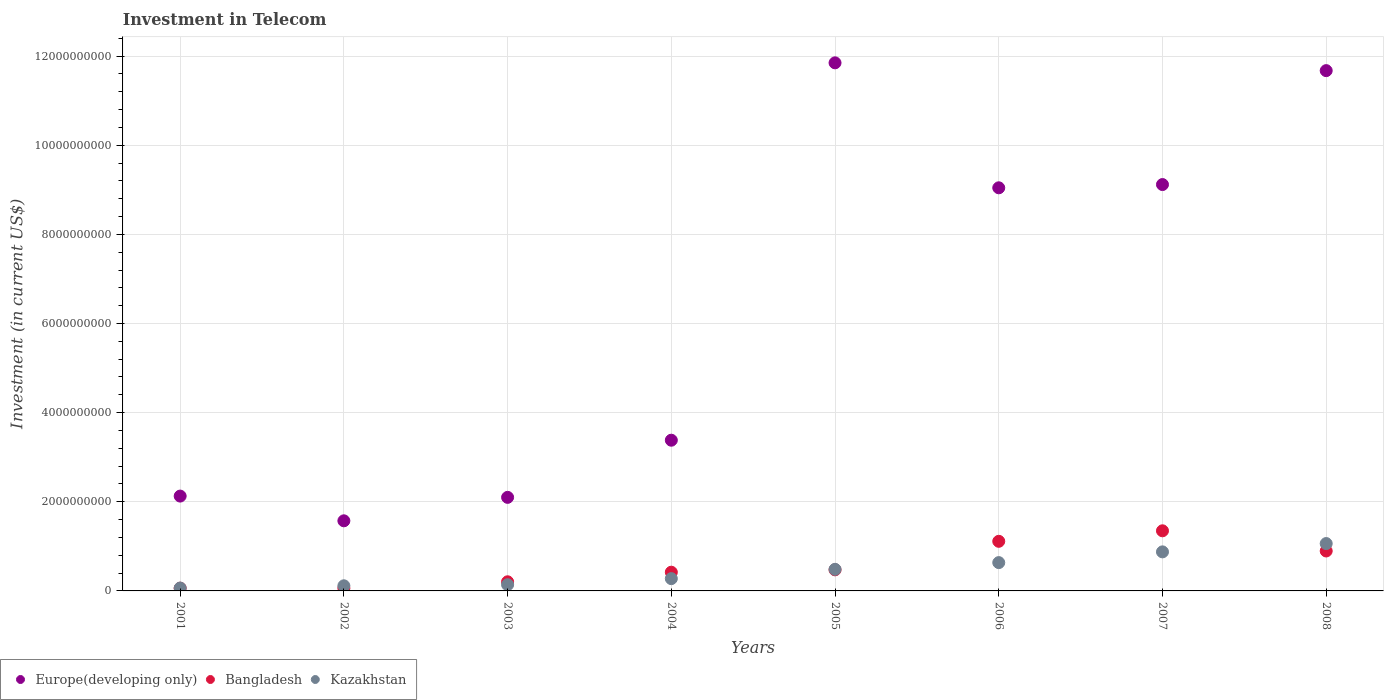What is the amount invested in telecom in Kazakhstan in 2008?
Make the answer very short. 1.06e+09. Across all years, what is the maximum amount invested in telecom in Bangladesh?
Ensure brevity in your answer.  1.35e+09. Across all years, what is the minimum amount invested in telecom in Kazakhstan?
Ensure brevity in your answer.  6.45e+07. In which year was the amount invested in telecom in Europe(developing only) maximum?
Make the answer very short. 2005. In which year was the amount invested in telecom in Europe(developing only) minimum?
Keep it short and to the point. 2002. What is the total amount invested in telecom in Bangladesh in the graph?
Keep it short and to the point. 4.58e+09. What is the difference between the amount invested in telecom in Europe(developing only) in 2005 and that in 2008?
Give a very brief answer. 1.75e+08. What is the difference between the amount invested in telecom in Bangladesh in 2001 and the amount invested in telecom in Kazakhstan in 2007?
Offer a very short reply. -8.15e+08. What is the average amount invested in telecom in Bangladesh per year?
Provide a succinct answer. 5.72e+08. In the year 2003, what is the difference between the amount invested in telecom in Kazakhstan and amount invested in telecom in Bangladesh?
Make the answer very short. -6.60e+07. What is the ratio of the amount invested in telecom in Bangladesh in 2001 to that in 2002?
Give a very brief answer. 1.01. Is the amount invested in telecom in Bangladesh in 2001 less than that in 2007?
Provide a succinct answer. Yes. Is the difference between the amount invested in telecom in Kazakhstan in 2002 and 2005 greater than the difference between the amount invested in telecom in Bangladesh in 2002 and 2005?
Your answer should be compact. Yes. What is the difference between the highest and the second highest amount invested in telecom in Bangladesh?
Make the answer very short. 2.36e+08. What is the difference between the highest and the lowest amount invested in telecom in Bangladesh?
Offer a terse response. 1.29e+09. Is the sum of the amount invested in telecom in Kazakhstan in 2002 and 2003 greater than the maximum amount invested in telecom in Europe(developing only) across all years?
Offer a terse response. No. Is it the case that in every year, the sum of the amount invested in telecom in Kazakhstan and amount invested in telecom in Bangladesh  is greater than the amount invested in telecom in Europe(developing only)?
Your answer should be compact. No. Is the amount invested in telecom in Kazakhstan strictly greater than the amount invested in telecom in Europe(developing only) over the years?
Offer a very short reply. No. What is the difference between two consecutive major ticks on the Y-axis?
Keep it short and to the point. 2.00e+09. Does the graph contain any zero values?
Keep it short and to the point. No. Does the graph contain grids?
Offer a very short reply. Yes. Where does the legend appear in the graph?
Your answer should be compact. Bottom left. How many legend labels are there?
Ensure brevity in your answer.  3. What is the title of the graph?
Give a very brief answer. Investment in Telecom. What is the label or title of the Y-axis?
Offer a terse response. Investment (in current US$). What is the Investment (in current US$) of Europe(developing only) in 2001?
Your response must be concise. 2.13e+09. What is the Investment (in current US$) of Bangladesh in 2001?
Give a very brief answer. 6.13e+07. What is the Investment (in current US$) in Kazakhstan in 2001?
Keep it short and to the point. 6.45e+07. What is the Investment (in current US$) in Europe(developing only) in 2002?
Make the answer very short. 1.57e+09. What is the Investment (in current US$) in Bangladesh in 2002?
Your response must be concise. 6.09e+07. What is the Investment (in current US$) of Kazakhstan in 2002?
Your response must be concise. 1.15e+08. What is the Investment (in current US$) in Europe(developing only) in 2003?
Your answer should be compact. 2.10e+09. What is the Investment (in current US$) of Bangladesh in 2003?
Your answer should be compact. 2.05e+08. What is the Investment (in current US$) of Kazakhstan in 2003?
Provide a short and direct response. 1.39e+08. What is the Investment (in current US$) of Europe(developing only) in 2004?
Offer a terse response. 3.38e+09. What is the Investment (in current US$) of Bangladesh in 2004?
Provide a short and direct response. 4.20e+08. What is the Investment (in current US$) in Kazakhstan in 2004?
Ensure brevity in your answer.  2.76e+08. What is the Investment (in current US$) in Europe(developing only) in 2005?
Make the answer very short. 1.18e+1. What is the Investment (in current US$) of Bangladesh in 2005?
Keep it short and to the point. 4.73e+08. What is the Investment (in current US$) in Kazakhstan in 2005?
Provide a succinct answer. 4.84e+08. What is the Investment (in current US$) in Europe(developing only) in 2006?
Give a very brief answer. 9.04e+09. What is the Investment (in current US$) of Bangladesh in 2006?
Provide a short and direct response. 1.11e+09. What is the Investment (in current US$) of Kazakhstan in 2006?
Offer a very short reply. 6.35e+08. What is the Investment (in current US$) in Europe(developing only) in 2007?
Provide a succinct answer. 9.12e+09. What is the Investment (in current US$) of Bangladesh in 2007?
Offer a very short reply. 1.35e+09. What is the Investment (in current US$) in Kazakhstan in 2007?
Your response must be concise. 8.76e+08. What is the Investment (in current US$) of Europe(developing only) in 2008?
Your answer should be compact. 1.17e+1. What is the Investment (in current US$) of Bangladesh in 2008?
Provide a short and direct response. 8.96e+08. What is the Investment (in current US$) of Kazakhstan in 2008?
Offer a terse response. 1.06e+09. Across all years, what is the maximum Investment (in current US$) in Europe(developing only)?
Provide a short and direct response. 1.18e+1. Across all years, what is the maximum Investment (in current US$) of Bangladesh?
Keep it short and to the point. 1.35e+09. Across all years, what is the maximum Investment (in current US$) in Kazakhstan?
Your answer should be very brief. 1.06e+09. Across all years, what is the minimum Investment (in current US$) of Europe(developing only)?
Keep it short and to the point. 1.57e+09. Across all years, what is the minimum Investment (in current US$) of Bangladesh?
Your response must be concise. 6.09e+07. Across all years, what is the minimum Investment (in current US$) in Kazakhstan?
Ensure brevity in your answer.  6.45e+07. What is the total Investment (in current US$) in Europe(developing only) in the graph?
Provide a short and direct response. 5.09e+1. What is the total Investment (in current US$) in Bangladesh in the graph?
Your response must be concise. 4.58e+09. What is the total Investment (in current US$) of Kazakhstan in the graph?
Your answer should be compact. 3.65e+09. What is the difference between the Investment (in current US$) of Europe(developing only) in 2001 and that in 2002?
Your answer should be compact. 5.55e+08. What is the difference between the Investment (in current US$) of Bangladesh in 2001 and that in 2002?
Provide a short and direct response. 4.00e+05. What is the difference between the Investment (in current US$) in Kazakhstan in 2001 and that in 2002?
Provide a short and direct response. -5.05e+07. What is the difference between the Investment (in current US$) of Europe(developing only) in 2001 and that in 2003?
Ensure brevity in your answer.  2.84e+07. What is the difference between the Investment (in current US$) of Bangladesh in 2001 and that in 2003?
Give a very brief answer. -1.44e+08. What is the difference between the Investment (in current US$) of Kazakhstan in 2001 and that in 2003?
Keep it short and to the point. -7.45e+07. What is the difference between the Investment (in current US$) in Europe(developing only) in 2001 and that in 2004?
Your response must be concise. -1.25e+09. What is the difference between the Investment (in current US$) of Bangladesh in 2001 and that in 2004?
Provide a short and direct response. -3.59e+08. What is the difference between the Investment (in current US$) of Kazakhstan in 2001 and that in 2004?
Make the answer very short. -2.11e+08. What is the difference between the Investment (in current US$) in Europe(developing only) in 2001 and that in 2005?
Your response must be concise. -9.72e+09. What is the difference between the Investment (in current US$) of Bangladesh in 2001 and that in 2005?
Offer a terse response. -4.12e+08. What is the difference between the Investment (in current US$) in Kazakhstan in 2001 and that in 2005?
Provide a succinct answer. -4.20e+08. What is the difference between the Investment (in current US$) in Europe(developing only) in 2001 and that in 2006?
Ensure brevity in your answer.  -6.92e+09. What is the difference between the Investment (in current US$) in Bangladesh in 2001 and that in 2006?
Keep it short and to the point. -1.05e+09. What is the difference between the Investment (in current US$) in Kazakhstan in 2001 and that in 2006?
Ensure brevity in your answer.  -5.71e+08. What is the difference between the Investment (in current US$) of Europe(developing only) in 2001 and that in 2007?
Keep it short and to the point. -6.99e+09. What is the difference between the Investment (in current US$) in Bangladesh in 2001 and that in 2007?
Your answer should be very brief. -1.29e+09. What is the difference between the Investment (in current US$) in Kazakhstan in 2001 and that in 2007?
Provide a short and direct response. -8.12e+08. What is the difference between the Investment (in current US$) in Europe(developing only) in 2001 and that in 2008?
Provide a short and direct response. -9.55e+09. What is the difference between the Investment (in current US$) of Bangladesh in 2001 and that in 2008?
Offer a very short reply. -8.35e+08. What is the difference between the Investment (in current US$) in Kazakhstan in 2001 and that in 2008?
Make the answer very short. -9.98e+08. What is the difference between the Investment (in current US$) in Europe(developing only) in 2002 and that in 2003?
Provide a short and direct response. -5.26e+08. What is the difference between the Investment (in current US$) of Bangladesh in 2002 and that in 2003?
Offer a terse response. -1.44e+08. What is the difference between the Investment (in current US$) of Kazakhstan in 2002 and that in 2003?
Your response must be concise. -2.40e+07. What is the difference between the Investment (in current US$) of Europe(developing only) in 2002 and that in 2004?
Ensure brevity in your answer.  -1.81e+09. What is the difference between the Investment (in current US$) in Bangladesh in 2002 and that in 2004?
Your response must be concise. -3.59e+08. What is the difference between the Investment (in current US$) of Kazakhstan in 2002 and that in 2004?
Your answer should be very brief. -1.61e+08. What is the difference between the Investment (in current US$) in Europe(developing only) in 2002 and that in 2005?
Your answer should be very brief. -1.03e+1. What is the difference between the Investment (in current US$) in Bangladesh in 2002 and that in 2005?
Keep it short and to the point. -4.12e+08. What is the difference between the Investment (in current US$) in Kazakhstan in 2002 and that in 2005?
Offer a terse response. -3.70e+08. What is the difference between the Investment (in current US$) of Europe(developing only) in 2002 and that in 2006?
Provide a succinct answer. -7.47e+09. What is the difference between the Investment (in current US$) in Bangladesh in 2002 and that in 2006?
Make the answer very short. -1.05e+09. What is the difference between the Investment (in current US$) of Kazakhstan in 2002 and that in 2006?
Your response must be concise. -5.20e+08. What is the difference between the Investment (in current US$) of Europe(developing only) in 2002 and that in 2007?
Provide a succinct answer. -7.54e+09. What is the difference between the Investment (in current US$) in Bangladesh in 2002 and that in 2007?
Provide a succinct answer. -1.29e+09. What is the difference between the Investment (in current US$) of Kazakhstan in 2002 and that in 2007?
Your answer should be compact. -7.61e+08. What is the difference between the Investment (in current US$) in Europe(developing only) in 2002 and that in 2008?
Offer a very short reply. -1.01e+1. What is the difference between the Investment (in current US$) in Bangladesh in 2002 and that in 2008?
Provide a succinct answer. -8.35e+08. What is the difference between the Investment (in current US$) of Kazakhstan in 2002 and that in 2008?
Your answer should be very brief. -9.48e+08. What is the difference between the Investment (in current US$) of Europe(developing only) in 2003 and that in 2004?
Keep it short and to the point. -1.28e+09. What is the difference between the Investment (in current US$) in Bangladesh in 2003 and that in 2004?
Keep it short and to the point. -2.15e+08. What is the difference between the Investment (in current US$) of Kazakhstan in 2003 and that in 2004?
Provide a succinct answer. -1.37e+08. What is the difference between the Investment (in current US$) in Europe(developing only) in 2003 and that in 2005?
Give a very brief answer. -9.75e+09. What is the difference between the Investment (in current US$) of Bangladesh in 2003 and that in 2005?
Offer a very short reply. -2.68e+08. What is the difference between the Investment (in current US$) of Kazakhstan in 2003 and that in 2005?
Provide a short and direct response. -3.46e+08. What is the difference between the Investment (in current US$) of Europe(developing only) in 2003 and that in 2006?
Provide a short and direct response. -6.94e+09. What is the difference between the Investment (in current US$) in Bangladesh in 2003 and that in 2006?
Provide a short and direct response. -9.08e+08. What is the difference between the Investment (in current US$) of Kazakhstan in 2003 and that in 2006?
Offer a terse response. -4.96e+08. What is the difference between the Investment (in current US$) in Europe(developing only) in 2003 and that in 2007?
Your answer should be very brief. -7.02e+09. What is the difference between the Investment (in current US$) in Bangladesh in 2003 and that in 2007?
Make the answer very short. -1.14e+09. What is the difference between the Investment (in current US$) of Kazakhstan in 2003 and that in 2007?
Provide a short and direct response. -7.37e+08. What is the difference between the Investment (in current US$) of Europe(developing only) in 2003 and that in 2008?
Your answer should be very brief. -9.57e+09. What is the difference between the Investment (in current US$) in Bangladesh in 2003 and that in 2008?
Provide a short and direct response. -6.91e+08. What is the difference between the Investment (in current US$) of Kazakhstan in 2003 and that in 2008?
Provide a succinct answer. -9.24e+08. What is the difference between the Investment (in current US$) in Europe(developing only) in 2004 and that in 2005?
Provide a short and direct response. -8.47e+09. What is the difference between the Investment (in current US$) of Bangladesh in 2004 and that in 2005?
Offer a very short reply. -5.30e+07. What is the difference between the Investment (in current US$) of Kazakhstan in 2004 and that in 2005?
Offer a very short reply. -2.09e+08. What is the difference between the Investment (in current US$) of Europe(developing only) in 2004 and that in 2006?
Provide a short and direct response. -5.66e+09. What is the difference between the Investment (in current US$) of Bangladesh in 2004 and that in 2006?
Give a very brief answer. -6.93e+08. What is the difference between the Investment (in current US$) of Kazakhstan in 2004 and that in 2006?
Your response must be concise. -3.60e+08. What is the difference between the Investment (in current US$) in Europe(developing only) in 2004 and that in 2007?
Offer a very short reply. -5.74e+09. What is the difference between the Investment (in current US$) in Bangladesh in 2004 and that in 2007?
Provide a succinct answer. -9.29e+08. What is the difference between the Investment (in current US$) of Kazakhstan in 2004 and that in 2007?
Your response must be concise. -6.00e+08. What is the difference between the Investment (in current US$) of Europe(developing only) in 2004 and that in 2008?
Make the answer very short. -8.29e+09. What is the difference between the Investment (in current US$) of Bangladesh in 2004 and that in 2008?
Your answer should be very brief. -4.76e+08. What is the difference between the Investment (in current US$) of Kazakhstan in 2004 and that in 2008?
Provide a succinct answer. -7.87e+08. What is the difference between the Investment (in current US$) of Europe(developing only) in 2005 and that in 2006?
Provide a short and direct response. 2.80e+09. What is the difference between the Investment (in current US$) in Bangladesh in 2005 and that in 2006?
Offer a very short reply. -6.40e+08. What is the difference between the Investment (in current US$) of Kazakhstan in 2005 and that in 2006?
Ensure brevity in your answer.  -1.51e+08. What is the difference between the Investment (in current US$) of Europe(developing only) in 2005 and that in 2007?
Your answer should be very brief. 2.73e+09. What is the difference between the Investment (in current US$) of Bangladesh in 2005 and that in 2007?
Your response must be concise. -8.76e+08. What is the difference between the Investment (in current US$) in Kazakhstan in 2005 and that in 2007?
Offer a very short reply. -3.92e+08. What is the difference between the Investment (in current US$) of Europe(developing only) in 2005 and that in 2008?
Keep it short and to the point. 1.75e+08. What is the difference between the Investment (in current US$) of Bangladesh in 2005 and that in 2008?
Provide a succinct answer. -4.23e+08. What is the difference between the Investment (in current US$) in Kazakhstan in 2005 and that in 2008?
Offer a very short reply. -5.78e+08. What is the difference between the Investment (in current US$) in Europe(developing only) in 2006 and that in 2007?
Keep it short and to the point. -7.30e+07. What is the difference between the Investment (in current US$) in Bangladesh in 2006 and that in 2007?
Offer a terse response. -2.36e+08. What is the difference between the Investment (in current US$) of Kazakhstan in 2006 and that in 2007?
Provide a succinct answer. -2.41e+08. What is the difference between the Investment (in current US$) of Europe(developing only) in 2006 and that in 2008?
Offer a very short reply. -2.63e+09. What is the difference between the Investment (in current US$) in Bangladesh in 2006 and that in 2008?
Offer a very short reply. 2.17e+08. What is the difference between the Investment (in current US$) in Kazakhstan in 2006 and that in 2008?
Your answer should be very brief. -4.27e+08. What is the difference between the Investment (in current US$) of Europe(developing only) in 2007 and that in 2008?
Offer a very short reply. -2.56e+09. What is the difference between the Investment (in current US$) in Bangladesh in 2007 and that in 2008?
Provide a succinct answer. 4.53e+08. What is the difference between the Investment (in current US$) of Kazakhstan in 2007 and that in 2008?
Provide a succinct answer. -1.86e+08. What is the difference between the Investment (in current US$) in Europe(developing only) in 2001 and the Investment (in current US$) in Bangladesh in 2002?
Keep it short and to the point. 2.07e+09. What is the difference between the Investment (in current US$) in Europe(developing only) in 2001 and the Investment (in current US$) in Kazakhstan in 2002?
Your response must be concise. 2.01e+09. What is the difference between the Investment (in current US$) in Bangladesh in 2001 and the Investment (in current US$) in Kazakhstan in 2002?
Offer a terse response. -5.37e+07. What is the difference between the Investment (in current US$) of Europe(developing only) in 2001 and the Investment (in current US$) of Bangladesh in 2003?
Make the answer very short. 1.92e+09. What is the difference between the Investment (in current US$) of Europe(developing only) in 2001 and the Investment (in current US$) of Kazakhstan in 2003?
Make the answer very short. 1.99e+09. What is the difference between the Investment (in current US$) of Bangladesh in 2001 and the Investment (in current US$) of Kazakhstan in 2003?
Provide a succinct answer. -7.77e+07. What is the difference between the Investment (in current US$) in Europe(developing only) in 2001 and the Investment (in current US$) in Bangladesh in 2004?
Your answer should be compact. 1.71e+09. What is the difference between the Investment (in current US$) in Europe(developing only) in 2001 and the Investment (in current US$) in Kazakhstan in 2004?
Your response must be concise. 1.85e+09. What is the difference between the Investment (in current US$) of Bangladesh in 2001 and the Investment (in current US$) of Kazakhstan in 2004?
Provide a short and direct response. -2.14e+08. What is the difference between the Investment (in current US$) of Europe(developing only) in 2001 and the Investment (in current US$) of Bangladesh in 2005?
Your answer should be compact. 1.65e+09. What is the difference between the Investment (in current US$) in Europe(developing only) in 2001 and the Investment (in current US$) in Kazakhstan in 2005?
Keep it short and to the point. 1.64e+09. What is the difference between the Investment (in current US$) in Bangladesh in 2001 and the Investment (in current US$) in Kazakhstan in 2005?
Offer a terse response. -4.23e+08. What is the difference between the Investment (in current US$) of Europe(developing only) in 2001 and the Investment (in current US$) of Bangladesh in 2006?
Give a very brief answer. 1.01e+09. What is the difference between the Investment (in current US$) of Europe(developing only) in 2001 and the Investment (in current US$) of Kazakhstan in 2006?
Give a very brief answer. 1.49e+09. What is the difference between the Investment (in current US$) in Bangladesh in 2001 and the Investment (in current US$) in Kazakhstan in 2006?
Your response must be concise. -5.74e+08. What is the difference between the Investment (in current US$) of Europe(developing only) in 2001 and the Investment (in current US$) of Bangladesh in 2007?
Keep it short and to the point. 7.79e+08. What is the difference between the Investment (in current US$) of Europe(developing only) in 2001 and the Investment (in current US$) of Kazakhstan in 2007?
Your answer should be compact. 1.25e+09. What is the difference between the Investment (in current US$) in Bangladesh in 2001 and the Investment (in current US$) in Kazakhstan in 2007?
Ensure brevity in your answer.  -8.15e+08. What is the difference between the Investment (in current US$) in Europe(developing only) in 2001 and the Investment (in current US$) in Bangladesh in 2008?
Offer a very short reply. 1.23e+09. What is the difference between the Investment (in current US$) of Europe(developing only) in 2001 and the Investment (in current US$) of Kazakhstan in 2008?
Offer a very short reply. 1.07e+09. What is the difference between the Investment (in current US$) in Bangladesh in 2001 and the Investment (in current US$) in Kazakhstan in 2008?
Offer a very short reply. -1.00e+09. What is the difference between the Investment (in current US$) in Europe(developing only) in 2002 and the Investment (in current US$) in Bangladesh in 2003?
Make the answer very short. 1.37e+09. What is the difference between the Investment (in current US$) in Europe(developing only) in 2002 and the Investment (in current US$) in Kazakhstan in 2003?
Give a very brief answer. 1.43e+09. What is the difference between the Investment (in current US$) in Bangladesh in 2002 and the Investment (in current US$) in Kazakhstan in 2003?
Keep it short and to the point. -7.81e+07. What is the difference between the Investment (in current US$) of Europe(developing only) in 2002 and the Investment (in current US$) of Bangladesh in 2004?
Your answer should be compact. 1.15e+09. What is the difference between the Investment (in current US$) in Europe(developing only) in 2002 and the Investment (in current US$) in Kazakhstan in 2004?
Keep it short and to the point. 1.30e+09. What is the difference between the Investment (in current US$) of Bangladesh in 2002 and the Investment (in current US$) of Kazakhstan in 2004?
Provide a short and direct response. -2.15e+08. What is the difference between the Investment (in current US$) of Europe(developing only) in 2002 and the Investment (in current US$) of Bangladesh in 2005?
Provide a succinct answer. 1.10e+09. What is the difference between the Investment (in current US$) of Europe(developing only) in 2002 and the Investment (in current US$) of Kazakhstan in 2005?
Give a very brief answer. 1.09e+09. What is the difference between the Investment (in current US$) of Bangladesh in 2002 and the Investment (in current US$) of Kazakhstan in 2005?
Keep it short and to the point. -4.24e+08. What is the difference between the Investment (in current US$) of Europe(developing only) in 2002 and the Investment (in current US$) of Bangladesh in 2006?
Ensure brevity in your answer.  4.60e+08. What is the difference between the Investment (in current US$) of Europe(developing only) in 2002 and the Investment (in current US$) of Kazakhstan in 2006?
Keep it short and to the point. 9.38e+08. What is the difference between the Investment (in current US$) in Bangladesh in 2002 and the Investment (in current US$) in Kazakhstan in 2006?
Ensure brevity in your answer.  -5.74e+08. What is the difference between the Investment (in current US$) in Europe(developing only) in 2002 and the Investment (in current US$) in Bangladesh in 2007?
Ensure brevity in your answer.  2.24e+08. What is the difference between the Investment (in current US$) in Europe(developing only) in 2002 and the Investment (in current US$) in Kazakhstan in 2007?
Provide a short and direct response. 6.97e+08. What is the difference between the Investment (in current US$) in Bangladesh in 2002 and the Investment (in current US$) in Kazakhstan in 2007?
Ensure brevity in your answer.  -8.15e+08. What is the difference between the Investment (in current US$) of Europe(developing only) in 2002 and the Investment (in current US$) of Bangladesh in 2008?
Your response must be concise. 6.77e+08. What is the difference between the Investment (in current US$) in Europe(developing only) in 2002 and the Investment (in current US$) in Kazakhstan in 2008?
Give a very brief answer. 5.10e+08. What is the difference between the Investment (in current US$) of Bangladesh in 2002 and the Investment (in current US$) of Kazakhstan in 2008?
Provide a short and direct response. -1.00e+09. What is the difference between the Investment (in current US$) of Europe(developing only) in 2003 and the Investment (in current US$) of Bangladesh in 2004?
Make the answer very short. 1.68e+09. What is the difference between the Investment (in current US$) in Europe(developing only) in 2003 and the Investment (in current US$) in Kazakhstan in 2004?
Your answer should be very brief. 1.82e+09. What is the difference between the Investment (in current US$) in Bangladesh in 2003 and the Investment (in current US$) in Kazakhstan in 2004?
Provide a succinct answer. -7.07e+07. What is the difference between the Investment (in current US$) in Europe(developing only) in 2003 and the Investment (in current US$) in Bangladesh in 2005?
Your response must be concise. 1.63e+09. What is the difference between the Investment (in current US$) of Europe(developing only) in 2003 and the Investment (in current US$) of Kazakhstan in 2005?
Provide a short and direct response. 1.61e+09. What is the difference between the Investment (in current US$) in Bangladesh in 2003 and the Investment (in current US$) in Kazakhstan in 2005?
Provide a succinct answer. -2.80e+08. What is the difference between the Investment (in current US$) in Europe(developing only) in 2003 and the Investment (in current US$) in Bangladesh in 2006?
Give a very brief answer. 9.86e+08. What is the difference between the Investment (in current US$) in Europe(developing only) in 2003 and the Investment (in current US$) in Kazakhstan in 2006?
Provide a short and direct response. 1.46e+09. What is the difference between the Investment (in current US$) of Bangladesh in 2003 and the Investment (in current US$) of Kazakhstan in 2006?
Your response must be concise. -4.30e+08. What is the difference between the Investment (in current US$) of Europe(developing only) in 2003 and the Investment (in current US$) of Bangladesh in 2007?
Provide a succinct answer. 7.51e+08. What is the difference between the Investment (in current US$) in Europe(developing only) in 2003 and the Investment (in current US$) in Kazakhstan in 2007?
Make the answer very short. 1.22e+09. What is the difference between the Investment (in current US$) of Bangladesh in 2003 and the Investment (in current US$) of Kazakhstan in 2007?
Keep it short and to the point. -6.71e+08. What is the difference between the Investment (in current US$) in Europe(developing only) in 2003 and the Investment (in current US$) in Bangladesh in 2008?
Make the answer very short. 1.20e+09. What is the difference between the Investment (in current US$) in Europe(developing only) in 2003 and the Investment (in current US$) in Kazakhstan in 2008?
Your answer should be compact. 1.04e+09. What is the difference between the Investment (in current US$) of Bangladesh in 2003 and the Investment (in current US$) of Kazakhstan in 2008?
Your answer should be compact. -8.58e+08. What is the difference between the Investment (in current US$) of Europe(developing only) in 2004 and the Investment (in current US$) of Bangladesh in 2005?
Your answer should be compact. 2.91e+09. What is the difference between the Investment (in current US$) of Europe(developing only) in 2004 and the Investment (in current US$) of Kazakhstan in 2005?
Provide a short and direct response. 2.90e+09. What is the difference between the Investment (in current US$) in Bangladesh in 2004 and the Investment (in current US$) in Kazakhstan in 2005?
Your answer should be very brief. -6.45e+07. What is the difference between the Investment (in current US$) of Europe(developing only) in 2004 and the Investment (in current US$) of Bangladesh in 2006?
Provide a short and direct response. 2.27e+09. What is the difference between the Investment (in current US$) in Europe(developing only) in 2004 and the Investment (in current US$) in Kazakhstan in 2006?
Ensure brevity in your answer.  2.75e+09. What is the difference between the Investment (in current US$) in Bangladesh in 2004 and the Investment (in current US$) in Kazakhstan in 2006?
Your response must be concise. -2.15e+08. What is the difference between the Investment (in current US$) in Europe(developing only) in 2004 and the Investment (in current US$) in Bangladesh in 2007?
Ensure brevity in your answer.  2.03e+09. What is the difference between the Investment (in current US$) in Europe(developing only) in 2004 and the Investment (in current US$) in Kazakhstan in 2007?
Offer a terse response. 2.51e+09. What is the difference between the Investment (in current US$) in Bangladesh in 2004 and the Investment (in current US$) in Kazakhstan in 2007?
Ensure brevity in your answer.  -4.56e+08. What is the difference between the Investment (in current US$) in Europe(developing only) in 2004 and the Investment (in current US$) in Bangladesh in 2008?
Offer a terse response. 2.49e+09. What is the difference between the Investment (in current US$) of Europe(developing only) in 2004 and the Investment (in current US$) of Kazakhstan in 2008?
Offer a very short reply. 2.32e+09. What is the difference between the Investment (in current US$) in Bangladesh in 2004 and the Investment (in current US$) in Kazakhstan in 2008?
Make the answer very short. -6.43e+08. What is the difference between the Investment (in current US$) in Europe(developing only) in 2005 and the Investment (in current US$) in Bangladesh in 2006?
Offer a terse response. 1.07e+1. What is the difference between the Investment (in current US$) in Europe(developing only) in 2005 and the Investment (in current US$) in Kazakhstan in 2006?
Your answer should be very brief. 1.12e+1. What is the difference between the Investment (in current US$) in Bangladesh in 2005 and the Investment (in current US$) in Kazakhstan in 2006?
Give a very brief answer. -1.62e+08. What is the difference between the Investment (in current US$) of Europe(developing only) in 2005 and the Investment (in current US$) of Bangladesh in 2007?
Make the answer very short. 1.05e+1. What is the difference between the Investment (in current US$) in Europe(developing only) in 2005 and the Investment (in current US$) in Kazakhstan in 2007?
Your response must be concise. 1.10e+1. What is the difference between the Investment (in current US$) in Bangladesh in 2005 and the Investment (in current US$) in Kazakhstan in 2007?
Offer a very short reply. -4.03e+08. What is the difference between the Investment (in current US$) in Europe(developing only) in 2005 and the Investment (in current US$) in Bangladesh in 2008?
Give a very brief answer. 1.10e+1. What is the difference between the Investment (in current US$) in Europe(developing only) in 2005 and the Investment (in current US$) in Kazakhstan in 2008?
Offer a terse response. 1.08e+1. What is the difference between the Investment (in current US$) of Bangladesh in 2005 and the Investment (in current US$) of Kazakhstan in 2008?
Keep it short and to the point. -5.90e+08. What is the difference between the Investment (in current US$) of Europe(developing only) in 2006 and the Investment (in current US$) of Bangladesh in 2007?
Give a very brief answer. 7.70e+09. What is the difference between the Investment (in current US$) of Europe(developing only) in 2006 and the Investment (in current US$) of Kazakhstan in 2007?
Your answer should be very brief. 8.17e+09. What is the difference between the Investment (in current US$) of Bangladesh in 2006 and the Investment (in current US$) of Kazakhstan in 2007?
Keep it short and to the point. 2.37e+08. What is the difference between the Investment (in current US$) in Europe(developing only) in 2006 and the Investment (in current US$) in Bangladesh in 2008?
Your answer should be very brief. 8.15e+09. What is the difference between the Investment (in current US$) in Europe(developing only) in 2006 and the Investment (in current US$) in Kazakhstan in 2008?
Keep it short and to the point. 7.98e+09. What is the difference between the Investment (in current US$) of Bangladesh in 2006 and the Investment (in current US$) of Kazakhstan in 2008?
Offer a terse response. 5.04e+07. What is the difference between the Investment (in current US$) of Europe(developing only) in 2007 and the Investment (in current US$) of Bangladesh in 2008?
Keep it short and to the point. 8.22e+09. What is the difference between the Investment (in current US$) of Europe(developing only) in 2007 and the Investment (in current US$) of Kazakhstan in 2008?
Provide a short and direct response. 8.05e+09. What is the difference between the Investment (in current US$) of Bangladesh in 2007 and the Investment (in current US$) of Kazakhstan in 2008?
Offer a very short reply. 2.86e+08. What is the average Investment (in current US$) in Europe(developing only) per year?
Your answer should be very brief. 6.36e+09. What is the average Investment (in current US$) of Bangladesh per year?
Keep it short and to the point. 5.72e+08. What is the average Investment (in current US$) in Kazakhstan per year?
Offer a terse response. 4.57e+08. In the year 2001, what is the difference between the Investment (in current US$) in Europe(developing only) and Investment (in current US$) in Bangladesh?
Ensure brevity in your answer.  2.07e+09. In the year 2001, what is the difference between the Investment (in current US$) of Europe(developing only) and Investment (in current US$) of Kazakhstan?
Offer a very short reply. 2.06e+09. In the year 2001, what is the difference between the Investment (in current US$) in Bangladesh and Investment (in current US$) in Kazakhstan?
Offer a terse response. -3.20e+06. In the year 2002, what is the difference between the Investment (in current US$) of Europe(developing only) and Investment (in current US$) of Bangladesh?
Your answer should be compact. 1.51e+09. In the year 2002, what is the difference between the Investment (in current US$) of Europe(developing only) and Investment (in current US$) of Kazakhstan?
Give a very brief answer. 1.46e+09. In the year 2002, what is the difference between the Investment (in current US$) of Bangladesh and Investment (in current US$) of Kazakhstan?
Provide a short and direct response. -5.41e+07. In the year 2003, what is the difference between the Investment (in current US$) of Europe(developing only) and Investment (in current US$) of Bangladesh?
Provide a short and direct response. 1.89e+09. In the year 2003, what is the difference between the Investment (in current US$) of Europe(developing only) and Investment (in current US$) of Kazakhstan?
Offer a very short reply. 1.96e+09. In the year 2003, what is the difference between the Investment (in current US$) of Bangladesh and Investment (in current US$) of Kazakhstan?
Provide a short and direct response. 6.60e+07. In the year 2004, what is the difference between the Investment (in current US$) of Europe(developing only) and Investment (in current US$) of Bangladesh?
Your answer should be very brief. 2.96e+09. In the year 2004, what is the difference between the Investment (in current US$) of Europe(developing only) and Investment (in current US$) of Kazakhstan?
Provide a short and direct response. 3.11e+09. In the year 2004, what is the difference between the Investment (in current US$) in Bangladesh and Investment (in current US$) in Kazakhstan?
Your answer should be compact. 1.44e+08. In the year 2005, what is the difference between the Investment (in current US$) of Europe(developing only) and Investment (in current US$) of Bangladesh?
Ensure brevity in your answer.  1.14e+1. In the year 2005, what is the difference between the Investment (in current US$) in Europe(developing only) and Investment (in current US$) in Kazakhstan?
Your answer should be very brief. 1.14e+1. In the year 2005, what is the difference between the Investment (in current US$) of Bangladesh and Investment (in current US$) of Kazakhstan?
Offer a terse response. -1.15e+07. In the year 2006, what is the difference between the Investment (in current US$) of Europe(developing only) and Investment (in current US$) of Bangladesh?
Your answer should be compact. 7.93e+09. In the year 2006, what is the difference between the Investment (in current US$) of Europe(developing only) and Investment (in current US$) of Kazakhstan?
Your response must be concise. 8.41e+09. In the year 2006, what is the difference between the Investment (in current US$) of Bangladesh and Investment (in current US$) of Kazakhstan?
Your answer should be very brief. 4.78e+08. In the year 2007, what is the difference between the Investment (in current US$) of Europe(developing only) and Investment (in current US$) of Bangladesh?
Offer a very short reply. 7.77e+09. In the year 2007, what is the difference between the Investment (in current US$) in Europe(developing only) and Investment (in current US$) in Kazakhstan?
Make the answer very short. 8.24e+09. In the year 2007, what is the difference between the Investment (in current US$) of Bangladesh and Investment (in current US$) of Kazakhstan?
Your response must be concise. 4.73e+08. In the year 2008, what is the difference between the Investment (in current US$) of Europe(developing only) and Investment (in current US$) of Bangladesh?
Give a very brief answer. 1.08e+1. In the year 2008, what is the difference between the Investment (in current US$) of Europe(developing only) and Investment (in current US$) of Kazakhstan?
Offer a terse response. 1.06e+1. In the year 2008, what is the difference between the Investment (in current US$) of Bangladesh and Investment (in current US$) of Kazakhstan?
Your response must be concise. -1.67e+08. What is the ratio of the Investment (in current US$) in Europe(developing only) in 2001 to that in 2002?
Offer a very short reply. 1.35. What is the ratio of the Investment (in current US$) in Bangladesh in 2001 to that in 2002?
Keep it short and to the point. 1.01. What is the ratio of the Investment (in current US$) in Kazakhstan in 2001 to that in 2002?
Provide a short and direct response. 0.56. What is the ratio of the Investment (in current US$) of Europe(developing only) in 2001 to that in 2003?
Offer a very short reply. 1.01. What is the ratio of the Investment (in current US$) in Bangladesh in 2001 to that in 2003?
Give a very brief answer. 0.3. What is the ratio of the Investment (in current US$) in Kazakhstan in 2001 to that in 2003?
Your response must be concise. 0.46. What is the ratio of the Investment (in current US$) of Europe(developing only) in 2001 to that in 2004?
Offer a very short reply. 0.63. What is the ratio of the Investment (in current US$) of Bangladesh in 2001 to that in 2004?
Provide a short and direct response. 0.15. What is the ratio of the Investment (in current US$) of Kazakhstan in 2001 to that in 2004?
Give a very brief answer. 0.23. What is the ratio of the Investment (in current US$) of Europe(developing only) in 2001 to that in 2005?
Ensure brevity in your answer.  0.18. What is the ratio of the Investment (in current US$) in Bangladesh in 2001 to that in 2005?
Your answer should be compact. 0.13. What is the ratio of the Investment (in current US$) in Kazakhstan in 2001 to that in 2005?
Provide a succinct answer. 0.13. What is the ratio of the Investment (in current US$) of Europe(developing only) in 2001 to that in 2006?
Provide a succinct answer. 0.24. What is the ratio of the Investment (in current US$) of Bangladesh in 2001 to that in 2006?
Offer a very short reply. 0.06. What is the ratio of the Investment (in current US$) in Kazakhstan in 2001 to that in 2006?
Offer a terse response. 0.1. What is the ratio of the Investment (in current US$) of Europe(developing only) in 2001 to that in 2007?
Give a very brief answer. 0.23. What is the ratio of the Investment (in current US$) in Bangladesh in 2001 to that in 2007?
Offer a terse response. 0.05. What is the ratio of the Investment (in current US$) of Kazakhstan in 2001 to that in 2007?
Offer a terse response. 0.07. What is the ratio of the Investment (in current US$) of Europe(developing only) in 2001 to that in 2008?
Give a very brief answer. 0.18. What is the ratio of the Investment (in current US$) of Bangladesh in 2001 to that in 2008?
Ensure brevity in your answer.  0.07. What is the ratio of the Investment (in current US$) of Kazakhstan in 2001 to that in 2008?
Ensure brevity in your answer.  0.06. What is the ratio of the Investment (in current US$) in Europe(developing only) in 2002 to that in 2003?
Make the answer very short. 0.75. What is the ratio of the Investment (in current US$) in Bangladesh in 2002 to that in 2003?
Provide a succinct answer. 0.3. What is the ratio of the Investment (in current US$) in Kazakhstan in 2002 to that in 2003?
Ensure brevity in your answer.  0.83. What is the ratio of the Investment (in current US$) of Europe(developing only) in 2002 to that in 2004?
Provide a succinct answer. 0.47. What is the ratio of the Investment (in current US$) in Bangladesh in 2002 to that in 2004?
Provide a succinct answer. 0.14. What is the ratio of the Investment (in current US$) of Kazakhstan in 2002 to that in 2004?
Offer a terse response. 0.42. What is the ratio of the Investment (in current US$) in Europe(developing only) in 2002 to that in 2005?
Keep it short and to the point. 0.13. What is the ratio of the Investment (in current US$) in Bangladesh in 2002 to that in 2005?
Ensure brevity in your answer.  0.13. What is the ratio of the Investment (in current US$) of Kazakhstan in 2002 to that in 2005?
Offer a very short reply. 0.24. What is the ratio of the Investment (in current US$) of Europe(developing only) in 2002 to that in 2006?
Give a very brief answer. 0.17. What is the ratio of the Investment (in current US$) in Bangladesh in 2002 to that in 2006?
Give a very brief answer. 0.05. What is the ratio of the Investment (in current US$) of Kazakhstan in 2002 to that in 2006?
Give a very brief answer. 0.18. What is the ratio of the Investment (in current US$) in Europe(developing only) in 2002 to that in 2007?
Give a very brief answer. 0.17. What is the ratio of the Investment (in current US$) in Bangladesh in 2002 to that in 2007?
Provide a succinct answer. 0.05. What is the ratio of the Investment (in current US$) of Kazakhstan in 2002 to that in 2007?
Give a very brief answer. 0.13. What is the ratio of the Investment (in current US$) of Europe(developing only) in 2002 to that in 2008?
Provide a short and direct response. 0.13. What is the ratio of the Investment (in current US$) in Bangladesh in 2002 to that in 2008?
Ensure brevity in your answer.  0.07. What is the ratio of the Investment (in current US$) in Kazakhstan in 2002 to that in 2008?
Give a very brief answer. 0.11. What is the ratio of the Investment (in current US$) of Europe(developing only) in 2003 to that in 2004?
Keep it short and to the point. 0.62. What is the ratio of the Investment (in current US$) in Bangladesh in 2003 to that in 2004?
Ensure brevity in your answer.  0.49. What is the ratio of the Investment (in current US$) of Kazakhstan in 2003 to that in 2004?
Your response must be concise. 0.5. What is the ratio of the Investment (in current US$) of Europe(developing only) in 2003 to that in 2005?
Offer a very short reply. 0.18. What is the ratio of the Investment (in current US$) in Bangladesh in 2003 to that in 2005?
Give a very brief answer. 0.43. What is the ratio of the Investment (in current US$) of Kazakhstan in 2003 to that in 2005?
Offer a terse response. 0.29. What is the ratio of the Investment (in current US$) in Europe(developing only) in 2003 to that in 2006?
Make the answer very short. 0.23. What is the ratio of the Investment (in current US$) in Bangladesh in 2003 to that in 2006?
Your response must be concise. 0.18. What is the ratio of the Investment (in current US$) in Kazakhstan in 2003 to that in 2006?
Your answer should be compact. 0.22. What is the ratio of the Investment (in current US$) in Europe(developing only) in 2003 to that in 2007?
Offer a terse response. 0.23. What is the ratio of the Investment (in current US$) in Bangladesh in 2003 to that in 2007?
Your answer should be very brief. 0.15. What is the ratio of the Investment (in current US$) in Kazakhstan in 2003 to that in 2007?
Offer a very short reply. 0.16. What is the ratio of the Investment (in current US$) of Europe(developing only) in 2003 to that in 2008?
Offer a terse response. 0.18. What is the ratio of the Investment (in current US$) in Bangladesh in 2003 to that in 2008?
Your response must be concise. 0.23. What is the ratio of the Investment (in current US$) in Kazakhstan in 2003 to that in 2008?
Ensure brevity in your answer.  0.13. What is the ratio of the Investment (in current US$) in Europe(developing only) in 2004 to that in 2005?
Keep it short and to the point. 0.29. What is the ratio of the Investment (in current US$) of Bangladesh in 2004 to that in 2005?
Give a very brief answer. 0.89. What is the ratio of the Investment (in current US$) of Kazakhstan in 2004 to that in 2005?
Offer a very short reply. 0.57. What is the ratio of the Investment (in current US$) in Europe(developing only) in 2004 to that in 2006?
Your answer should be compact. 0.37. What is the ratio of the Investment (in current US$) in Bangladesh in 2004 to that in 2006?
Keep it short and to the point. 0.38. What is the ratio of the Investment (in current US$) of Kazakhstan in 2004 to that in 2006?
Offer a very short reply. 0.43. What is the ratio of the Investment (in current US$) in Europe(developing only) in 2004 to that in 2007?
Give a very brief answer. 0.37. What is the ratio of the Investment (in current US$) in Bangladesh in 2004 to that in 2007?
Keep it short and to the point. 0.31. What is the ratio of the Investment (in current US$) in Kazakhstan in 2004 to that in 2007?
Offer a very short reply. 0.31. What is the ratio of the Investment (in current US$) of Europe(developing only) in 2004 to that in 2008?
Ensure brevity in your answer.  0.29. What is the ratio of the Investment (in current US$) of Bangladesh in 2004 to that in 2008?
Provide a short and direct response. 0.47. What is the ratio of the Investment (in current US$) of Kazakhstan in 2004 to that in 2008?
Keep it short and to the point. 0.26. What is the ratio of the Investment (in current US$) of Europe(developing only) in 2005 to that in 2006?
Your answer should be very brief. 1.31. What is the ratio of the Investment (in current US$) in Bangladesh in 2005 to that in 2006?
Keep it short and to the point. 0.42. What is the ratio of the Investment (in current US$) in Kazakhstan in 2005 to that in 2006?
Make the answer very short. 0.76. What is the ratio of the Investment (in current US$) in Europe(developing only) in 2005 to that in 2007?
Ensure brevity in your answer.  1.3. What is the ratio of the Investment (in current US$) of Bangladesh in 2005 to that in 2007?
Provide a short and direct response. 0.35. What is the ratio of the Investment (in current US$) of Kazakhstan in 2005 to that in 2007?
Offer a very short reply. 0.55. What is the ratio of the Investment (in current US$) in Europe(developing only) in 2005 to that in 2008?
Your answer should be compact. 1.01. What is the ratio of the Investment (in current US$) of Bangladesh in 2005 to that in 2008?
Your response must be concise. 0.53. What is the ratio of the Investment (in current US$) in Kazakhstan in 2005 to that in 2008?
Your answer should be very brief. 0.46. What is the ratio of the Investment (in current US$) in Europe(developing only) in 2006 to that in 2007?
Ensure brevity in your answer.  0.99. What is the ratio of the Investment (in current US$) of Bangladesh in 2006 to that in 2007?
Make the answer very short. 0.83. What is the ratio of the Investment (in current US$) of Kazakhstan in 2006 to that in 2007?
Keep it short and to the point. 0.72. What is the ratio of the Investment (in current US$) in Europe(developing only) in 2006 to that in 2008?
Your response must be concise. 0.77. What is the ratio of the Investment (in current US$) in Bangladesh in 2006 to that in 2008?
Your answer should be very brief. 1.24. What is the ratio of the Investment (in current US$) in Kazakhstan in 2006 to that in 2008?
Provide a succinct answer. 0.6. What is the ratio of the Investment (in current US$) in Europe(developing only) in 2007 to that in 2008?
Make the answer very short. 0.78. What is the ratio of the Investment (in current US$) of Bangladesh in 2007 to that in 2008?
Your answer should be compact. 1.51. What is the ratio of the Investment (in current US$) in Kazakhstan in 2007 to that in 2008?
Provide a short and direct response. 0.82. What is the difference between the highest and the second highest Investment (in current US$) of Europe(developing only)?
Your answer should be very brief. 1.75e+08. What is the difference between the highest and the second highest Investment (in current US$) of Bangladesh?
Your response must be concise. 2.36e+08. What is the difference between the highest and the second highest Investment (in current US$) of Kazakhstan?
Provide a short and direct response. 1.86e+08. What is the difference between the highest and the lowest Investment (in current US$) in Europe(developing only)?
Offer a very short reply. 1.03e+1. What is the difference between the highest and the lowest Investment (in current US$) in Bangladesh?
Your response must be concise. 1.29e+09. What is the difference between the highest and the lowest Investment (in current US$) in Kazakhstan?
Your answer should be compact. 9.98e+08. 